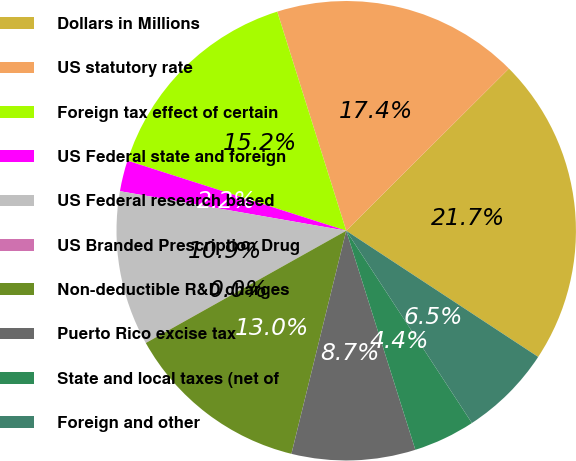Convert chart to OTSL. <chart><loc_0><loc_0><loc_500><loc_500><pie_chart><fcel>Dollars in Millions<fcel>US statutory rate<fcel>Foreign tax effect of certain<fcel>US Federal state and foreign<fcel>US Federal research based<fcel>US Branded Prescription Drug<fcel>Non-deductible R&D charges<fcel>Puerto Rico excise tax<fcel>State and local taxes (net of<fcel>Foreign and other<nl><fcel>21.73%<fcel>17.38%<fcel>15.21%<fcel>2.18%<fcel>10.87%<fcel>0.01%<fcel>13.04%<fcel>8.7%<fcel>4.35%<fcel>6.53%<nl></chart> 